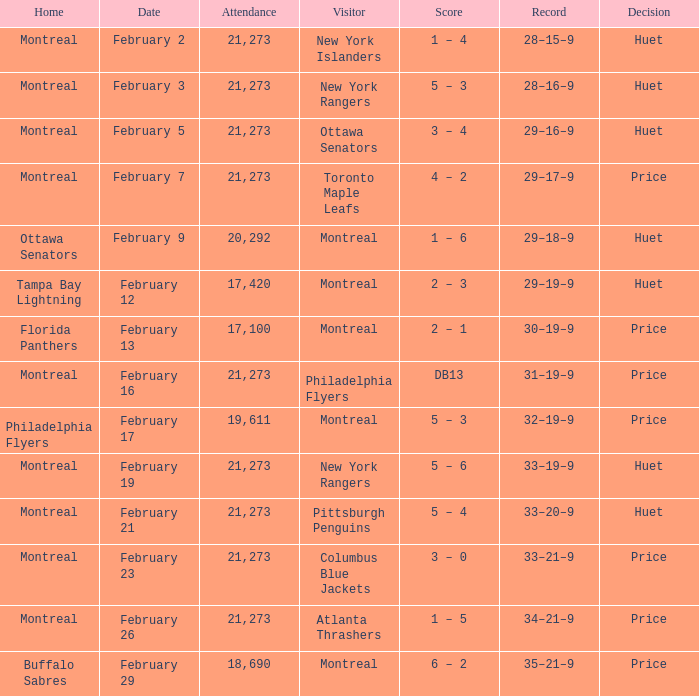What was the date of the game when the Canadiens had a record of 31–19–9? February 16. 